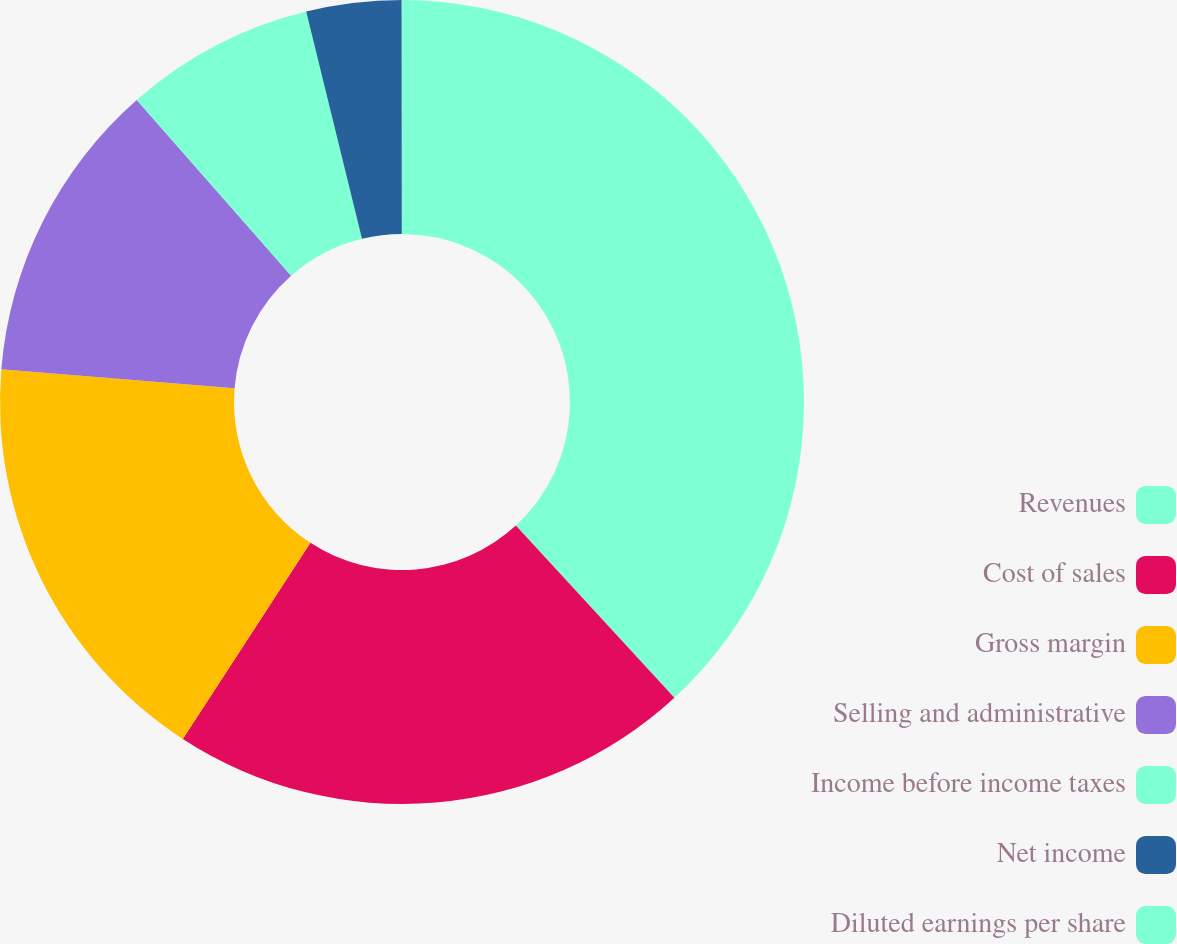Convert chart. <chart><loc_0><loc_0><loc_500><loc_500><pie_chart><fcel>Revenues<fcel>Cost of sales<fcel>Gross margin<fcel>Selling and administrative<fcel>Income before income taxes<fcel>Net income<fcel>Diluted earnings per share<nl><fcel>38.15%<fcel>21.03%<fcel>17.12%<fcel>12.23%<fcel>7.64%<fcel>3.82%<fcel>0.01%<nl></chart> 